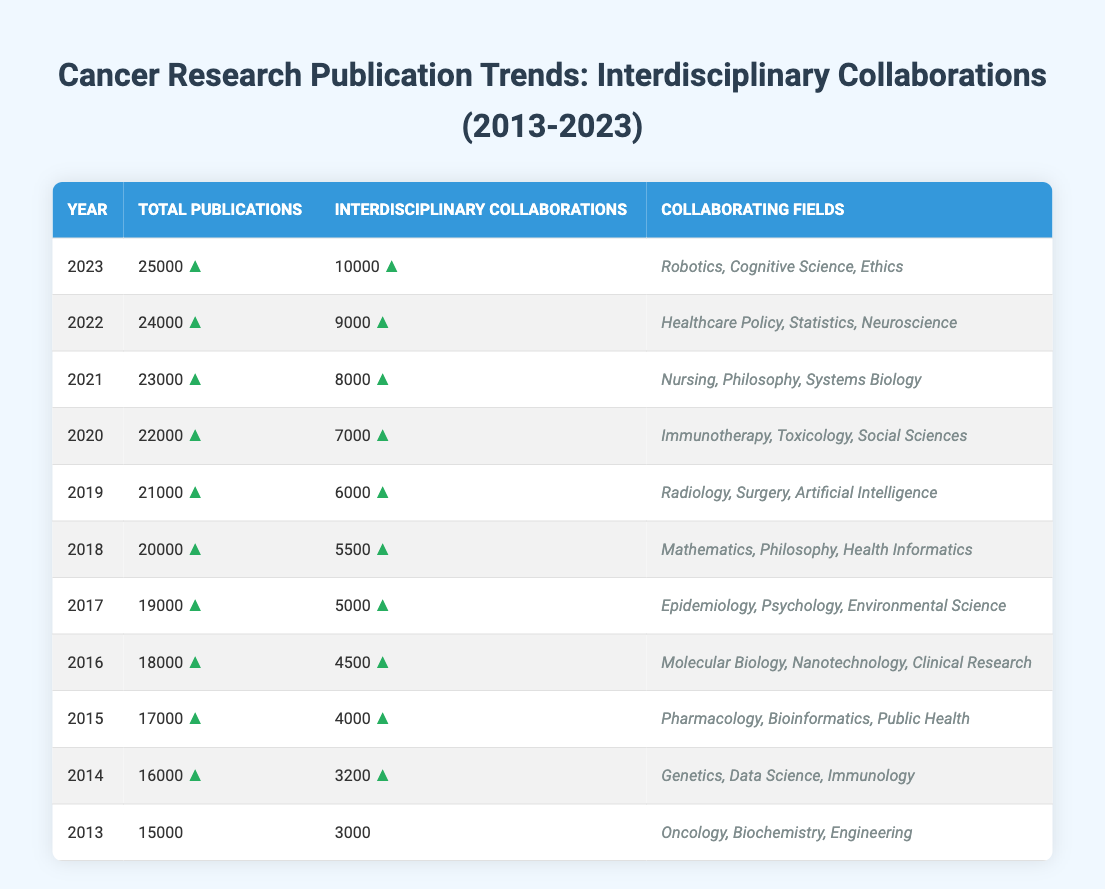What year saw the highest total number of publications in cancer research? By examining the "Total Publications" column in the table, we can observe that the highest value is 25000, which corresponds to the year 2023.
Answer: 2023 How many interdisciplinary collaborations were recorded in 2016? Looking at the "Interdisciplinary Collaborations" column for the year 2016, the value shown is 4500.
Answer: 4500 What is the trend in total publications from 2013 to 2023? Counting the values in the "Total Publications" column from 2013 (15000) to 2023 (25000), we notice that the number of publications increases each year, showing a clear upward trend.
Answer: Upward trend Which year had the lowest number of interdisciplinary collaborations? Referring to the "Interdisciplinary Collaborations" column, we find that 2013 had the lowest number at 3000.
Answer: 2013 What is the average number of interdisciplinary collaborations over the past decade? To calculate the average, sum the values of interdisciplinary collaborations from 2013 to 2023 (3000 + 3200 + 4000 + 4500 + 5000 + 5500 + 6000 + 7000 + 8000 + 9000 + 10000 = 49500), and then divide by the number of years (11): 49500 / 11 = 4500. Therefore, the average is 4500.
Answer: 4500 In which year were the most diverse collaborating fields listed? Checking the "Collaborating Fields" column, we see that each year lists three collaborating fields, but looking for diversity can be subjective; however, 2023 features "Robotics, Cognitive Science, Ethics," which represents emerging, rather unique fields in cancer research.
Answer: 2023 Did the number of total publications in 2022 exceed that of 2018? Comparing the total publications for 2022 (24000) and 2018 (20000), we see that 24000 is greater than 20000, confirming that publications in 2022 did exceed those in 2018.
Answer: Yes How many more interdisciplinary collaborations were there in 2021 compared to 2015? We find the number of interdisciplinary collaborations for 2021 is 8000 and for 2015 it is 4000. Thus, we subtract: 8000 - 4000 = 4000, indicating that there were 4000 more collaborations in 2021 than in 2015.
Answer: 4000 Which collaborating fields were associated with the highest number of interdisciplinary collaborations in 2023? The fields listed for 2023 are "Robotics, Cognitive Science, Ethics," and there were 10000 interdisciplinary collaborations, the highest for that year.
Answer: Robotics, Cognitive Science, Ethics Has the increase in total publications always been greater than the increase in interdisciplinary collaborations each year? By reviewing each year's total publication and interdisciplinary collaboration increases, we see every year’s total publication increase is higher than the collaborations’ increase, confirming a systematic gap: 2014-2013 = 1000 vs 200, 2015-2014 = 1000 vs 1800, and so on.
Answer: Yes 